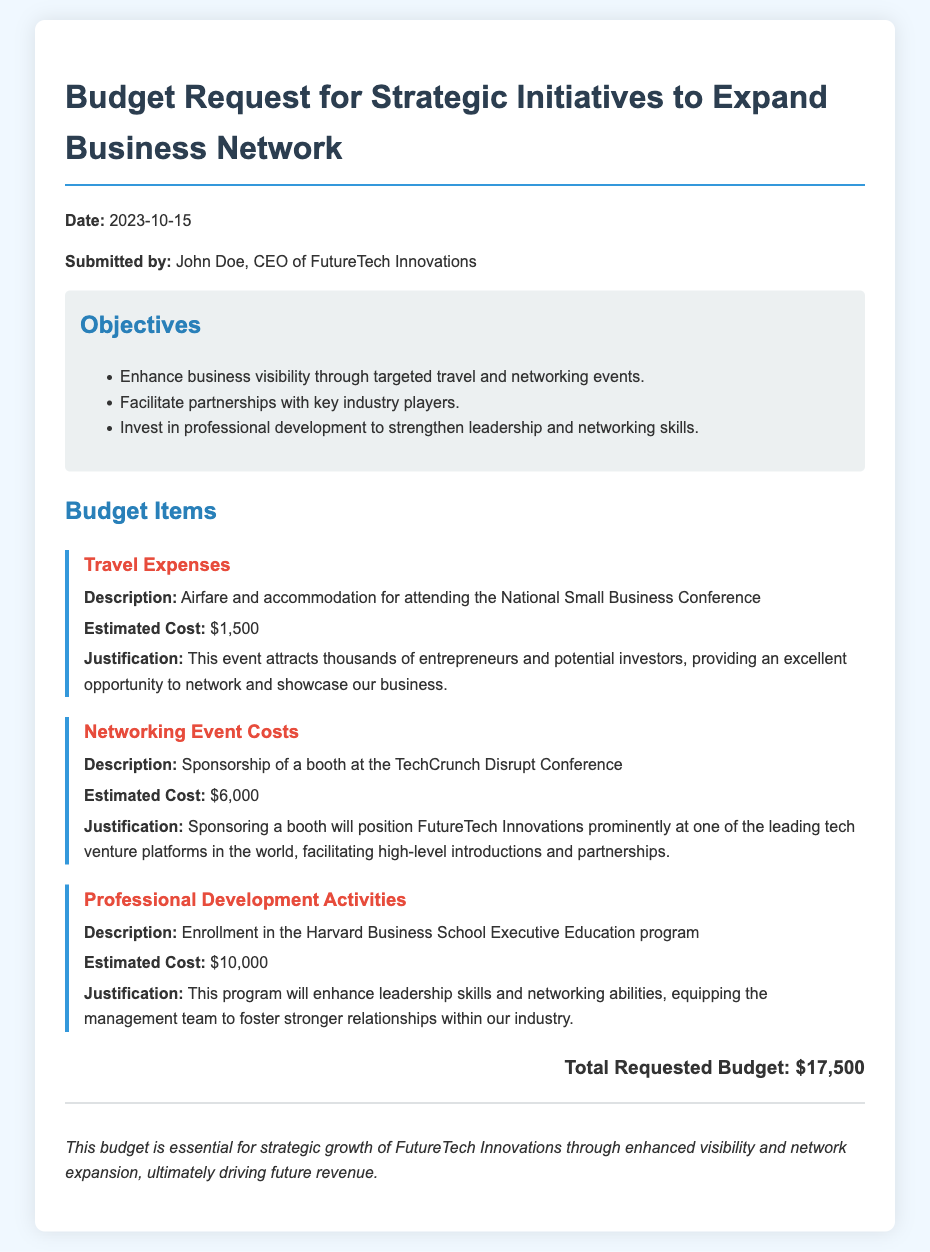what is the total requested budget? The total requested budget is explicitly stated in the document as the sum of all estimated costs.
Answer: $17,500 who is the submitted by? The document provides the name of the person who submitted the budget request.
Answer: John Doe what is the estimated cost for travel expenses? The travel expenses section specifies the estimated cost associated with that item.
Answer: $1,500 what is the objective related to partnerships? The objectives include a specific aim to form relationships with others in the industry.
Answer: Facilitate partnerships with key industry players what is the estimated cost of professional development activities? The document lists the cost associated with professional development initiatives.
Answer: $10,000 which event is mentioned for networking event costs? The document states a specific event for which sponsorship is requested.
Answer: TechCrunch Disrupt Conference what is the justification for the travel expenses? The document details the rationale behind incurring travel expenses for the particular event.
Answer: Excellent opportunity to network and showcase our business how much is allocated for networking event costs? The document specifies the financial allocation for the costs incurred during networking events.
Answer: $6,000 what program is mentioned for professional development? The document names the specific program for which enrollment costs are being requested.
Answer: Harvard Business School Executive Education program 